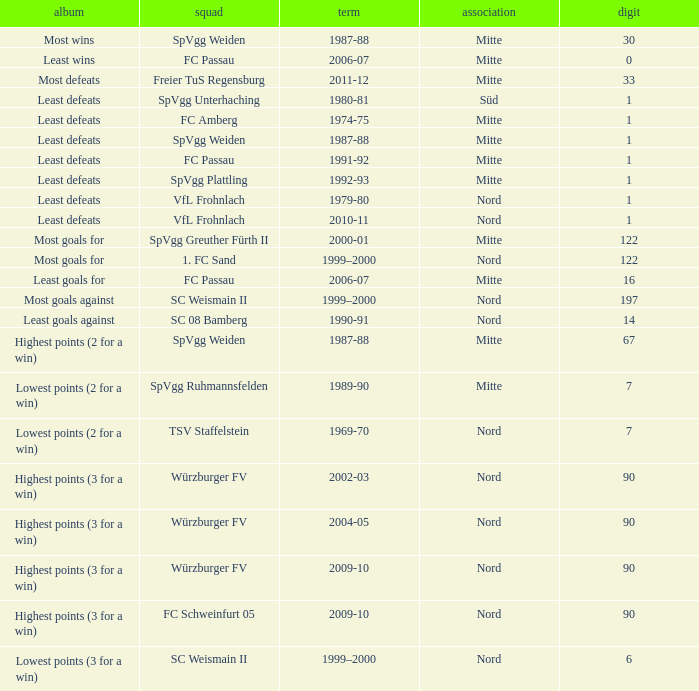What league has a number less than 122, and least wins as the record? Mitte. 